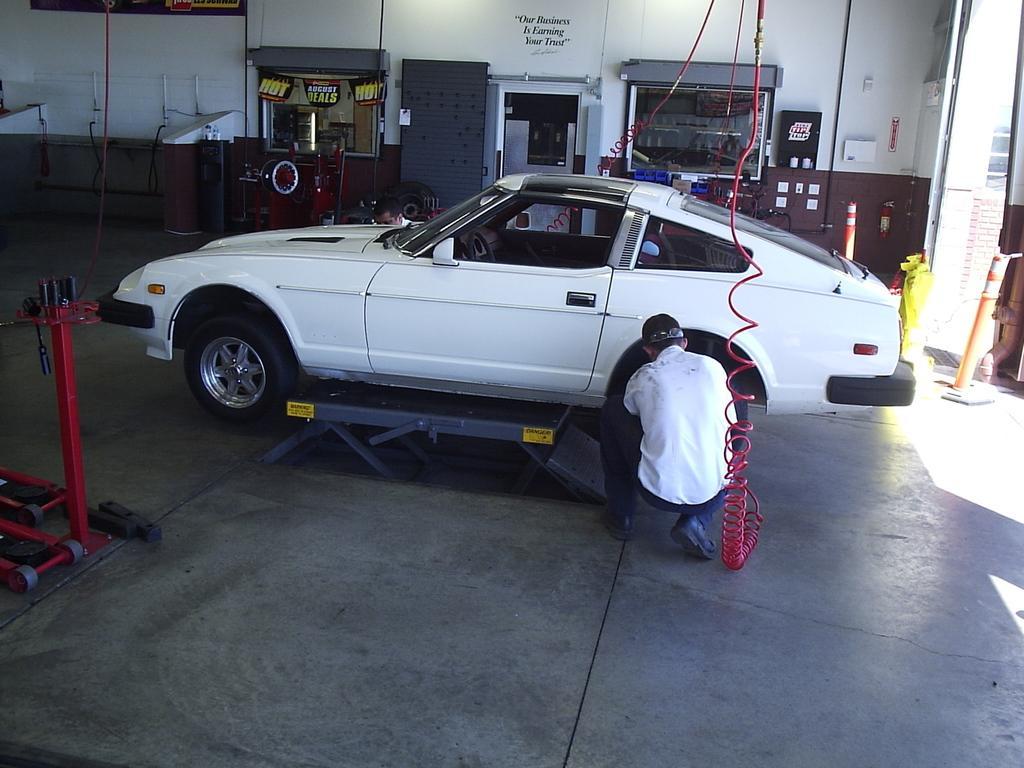Could you give a brief overview of what you see in this image? In the middle it is a car which is in white color. Here a man is repairing it, he wore a white color dress. 